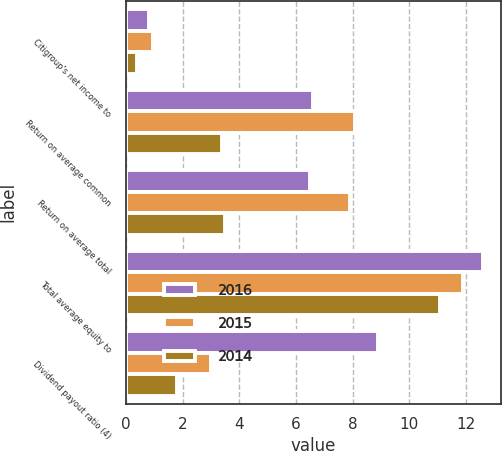<chart> <loc_0><loc_0><loc_500><loc_500><stacked_bar_chart><ecel><fcel>Citigroup's net income to<fcel>Return on average common<fcel>Return on average total<fcel>Total average equity to<fcel>Dividend payout ratio (4)<nl><fcel>2016<fcel>0.82<fcel>6.6<fcel>6.5<fcel>12.6<fcel>8.9<nl><fcel>2015<fcel>0.95<fcel>8.1<fcel>7.9<fcel>11.9<fcel>3<nl><fcel>2014<fcel>0.39<fcel>3.4<fcel>3.5<fcel>11.1<fcel>1.8<nl></chart> 